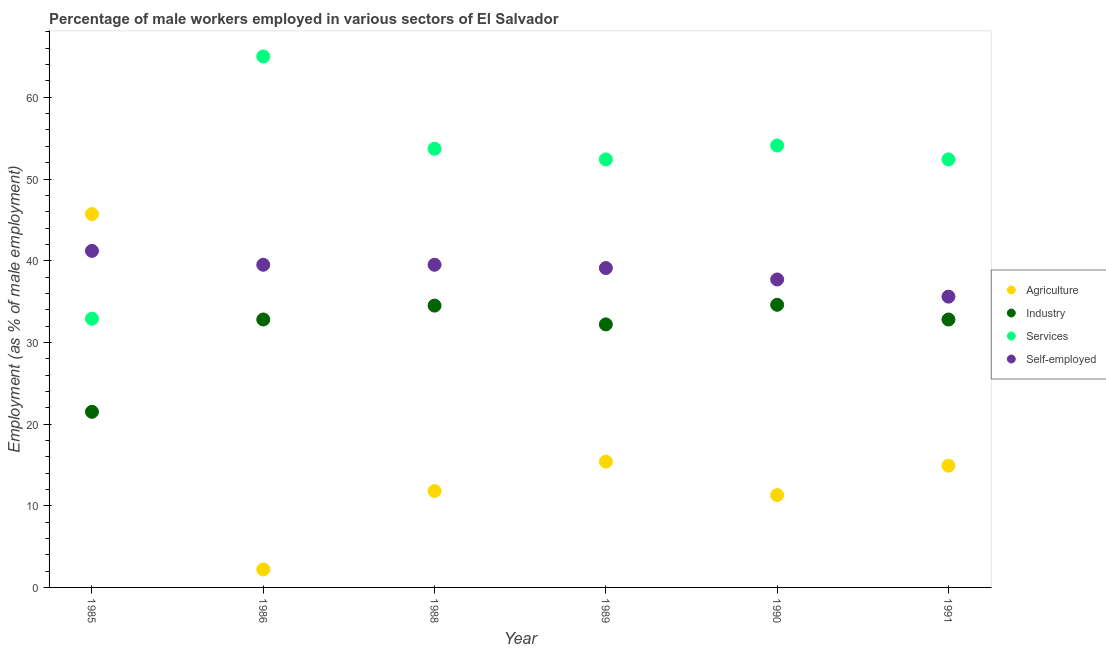How many different coloured dotlines are there?
Ensure brevity in your answer.  4. What is the percentage of male workers in agriculture in 1991?
Give a very brief answer. 14.9. Across all years, what is the maximum percentage of male workers in industry?
Your response must be concise. 34.6. Across all years, what is the minimum percentage of self employed male workers?
Give a very brief answer. 35.6. In which year was the percentage of male workers in services maximum?
Your answer should be compact. 1986. In which year was the percentage of self employed male workers minimum?
Your answer should be very brief. 1991. What is the total percentage of self employed male workers in the graph?
Your response must be concise. 232.6. What is the difference between the percentage of self employed male workers in 1985 and that in 1986?
Ensure brevity in your answer.  1.7. What is the difference between the percentage of self employed male workers in 1985 and the percentage of male workers in agriculture in 1991?
Make the answer very short. 26.3. What is the average percentage of male workers in agriculture per year?
Make the answer very short. 16.88. In the year 1990, what is the difference between the percentage of male workers in agriculture and percentage of male workers in industry?
Ensure brevity in your answer.  -23.3. What is the ratio of the percentage of male workers in industry in 1985 to that in 1989?
Offer a terse response. 0.67. What is the difference between the highest and the second highest percentage of male workers in services?
Ensure brevity in your answer.  10.9. What is the difference between the highest and the lowest percentage of male workers in agriculture?
Provide a succinct answer. 43.5. In how many years, is the percentage of male workers in industry greater than the average percentage of male workers in industry taken over all years?
Keep it short and to the point. 5. Is the sum of the percentage of self employed male workers in 1985 and 1991 greater than the maximum percentage of male workers in agriculture across all years?
Your answer should be compact. Yes. Is it the case that in every year, the sum of the percentage of male workers in industry and percentage of male workers in agriculture is greater than the sum of percentage of self employed male workers and percentage of male workers in services?
Make the answer very short. No. Is it the case that in every year, the sum of the percentage of male workers in agriculture and percentage of male workers in industry is greater than the percentage of male workers in services?
Give a very brief answer. No. Is the percentage of self employed male workers strictly less than the percentage of male workers in industry over the years?
Your answer should be very brief. No. Are the values on the major ticks of Y-axis written in scientific E-notation?
Make the answer very short. No. Does the graph contain any zero values?
Your response must be concise. No. Does the graph contain grids?
Ensure brevity in your answer.  No. Where does the legend appear in the graph?
Keep it short and to the point. Center right. What is the title of the graph?
Your response must be concise. Percentage of male workers employed in various sectors of El Salvador. Does "UNAIDS" appear as one of the legend labels in the graph?
Your response must be concise. No. What is the label or title of the X-axis?
Your answer should be compact. Year. What is the label or title of the Y-axis?
Offer a very short reply. Employment (as % of male employment). What is the Employment (as % of male employment) of Agriculture in 1985?
Provide a succinct answer. 45.7. What is the Employment (as % of male employment) of Services in 1985?
Make the answer very short. 32.9. What is the Employment (as % of male employment) in Self-employed in 1985?
Offer a very short reply. 41.2. What is the Employment (as % of male employment) of Agriculture in 1986?
Offer a terse response. 2.2. What is the Employment (as % of male employment) in Industry in 1986?
Your answer should be very brief. 32.8. What is the Employment (as % of male employment) of Self-employed in 1986?
Your answer should be compact. 39.5. What is the Employment (as % of male employment) in Agriculture in 1988?
Make the answer very short. 11.8. What is the Employment (as % of male employment) in Industry in 1988?
Provide a short and direct response. 34.5. What is the Employment (as % of male employment) of Services in 1988?
Offer a very short reply. 53.7. What is the Employment (as % of male employment) of Self-employed in 1988?
Provide a succinct answer. 39.5. What is the Employment (as % of male employment) of Agriculture in 1989?
Give a very brief answer. 15.4. What is the Employment (as % of male employment) in Industry in 1989?
Provide a succinct answer. 32.2. What is the Employment (as % of male employment) in Services in 1989?
Provide a short and direct response. 52.4. What is the Employment (as % of male employment) in Self-employed in 1989?
Offer a very short reply. 39.1. What is the Employment (as % of male employment) in Agriculture in 1990?
Make the answer very short. 11.3. What is the Employment (as % of male employment) of Industry in 1990?
Give a very brief answer. 34.6. What is the Employment (as % of male employment) in Services in 1990?
Give a very brief answer. 54.1. What is the Employment (as % of male employment) of Self-employed in 1990?
Your answer should be very brief. 37.7. What is the Employment (as % of male employment) in Agriculture in 1991?
Offer a terse response. 14.9. What is the Employment (as % of male employment) of Industry in 1991?
Give a very brief answer. 32.8. What is the Employment (as % of male employment) in Services in 1991?
Ensure brevity in your answer.  52.4. What is the Employment (as % of male employment) in Self-employed in 1991?
Provide a succinct answer. 35.6. Across all years, what is the maximum Employment (as % of male employment) in Agriculture?
Make the answer very short. 45.7. Across all years, what is the maximum Employment (as % of male employment) of Industry?
Offer a terse response. 34.6. Across all years, what is the maximum Employment (as % of male employment) of Services?
Your answer should be very brief. 65. Across all years, what is the maximum Employment (as % of male employment) of Self-employed?
Make the answer very short. 41.2. Across all years, what is the minimum Employment (as % of male employment) of Agriculture?
Offer a very short reply. 2.2. Across all years, what is the minimum Employment (as % of male employment) in Industry?
Ensure brevity in your answer.  21.5. Across all years, what is the minimum Employment (as % of male employment) of Services?
Ensure brevity in your answer.  32.9. Across all years, what is the minimum Employment (as % of male employment) of Self-employed?
Your answer should be compact. 35.6. What is the total Employment (as % of male employment) of Agriculture in the graph?
Offer a very short reply. 101.3. What is the total Employment (as % of male employment) of Industry in the graph?
Provide a succinct answer. 188.4. What is the total Employment (as % of male employment) in Services in the graph?
Your answer should be compact. 310.5. What is the total Employment (as % of male employment) in Self-employed in the graph?
Give a very brief answer. 232.6. What is the difference between the Employment (as % of male employment) in Agriculture in 1985 and that in 1986?
Provide a succinct answer. 43.5. What is the difference between the Employment (as % of male employment) in Industry in 1985 and that in 1986?
Make the answer very short. -11.3. What is the difference between the Employment (as % of male employment) of Services in 1985 and that in 1986?
Your answer should be very brief. -32.1. What is the difference between the Employment (as % of male employment) of Agriculture in 1985 and that in 1988?
Your answer should be very brief. 33.9. What is the difference between the Employment (as % of male employment) of Services in 1985 and that in 1988?
Your response must be concise. -20.8. What is the difference between the Employment (as % of male employment) in Self-employed in 1985 and that in 1988?
Your response must be concise. 1.7. What is the difference between the Employment (as % of male employment) of Agriculture in 1985 and that in 1989?
Make the answer very short. 30.3. What is the difference between the Employment (as % of male employment) in Industry in 1985 and that in 1989?
Keep it short and to the point. -10.7. What is the difference between the Employment (as % of male employment) of Services in 1985 and that in 1989?
Ensure brevity in your answer.  -19.5. What is the difference between the Employment (as % of male employment) in Self-employed in 1985 and that in 1989?
Make the answer very short. 2.1. What is the difference between the Employment (as % of male employment) of Agriculture in 1985 and that in 1990?
Your answer should be very brief. 34.4. What is the difference between the Employment (as % of male employment) in Services in 1985 and that in 1990?
Offer a terse response. -21.2. What is the difference between the Employment (as % of male employment) of Agriculture in 1985 and that in 1991?
Your answer should be compact. 30.8. What is the difference between the Employment (as % of male employment) in Services in 1985 and that in 1991?
Offer a terse response. -19.5. What is the difference between the Employment (as % of male employment) in Self-employed in 1985 and that in 1991?
Offer a terse response. 5.6. What is the difference between the Employment (as % of male employment) of Agriculture in 1986 and that in 1988?
Offer a terse response. -9.6. What is the difference between the Employment (as % of male employment) of Services in 1986 and that in 1989?
Provide a succinct answer. 12.6. What is the difference between the Employment (as % of male employment) of Agriculture in 1986 and that in 1990?
Make the answer very short. -9.1. What is the difference between the Employment (as % of male employment) in Industry in 1986 and that in 1990?
Offer a terse response. -1.8. What is the difference between the Employment (as % of male employment) of Services in 1986 and that in 1990?
Your answer should be compact. 10.9. What is the difference between the Employment (as % of male employment) in Industry in 1986 and that in 1991?
Ensure brevity in your answer.  0. What is the difference between the Employment (as % of male employment) of Self-employed in 1986 and that in 1991?
Your answer should be compact. 3.9. What is the difference between the Employment (as % of male employment) of Agriculture in 1988 and that in 1989?
Your answer should be very brief. -3.6. What is the difference between the Employment (as % of male employment) in Services in 1988 and that in 1989?
Give a very brief answer. 1.3. What is the difference between the Employment (as % of male employment) of Self-employed in 1988 and that in 1989?
Make the answer very short. 0.4. What is the difference between the Employment (as % of male employment) in Agriculture in 1988 and that in 1990?
Offer a terse response. 0.5. What is the difference between the Employment (as % of male employment) in Industry in 1988 and that in 1990?
Offer a very short reply. -0.1. What is the difference between the Employment (as % of male employment) in Services in 1988 and that in 1990?
Your response must be concise. -0.4. What is the difference between the Employment (as % of male employment) of Self-employed in 1988 and that in 1990?
Your answer should be very brief. 1.8. What is the difference between the Employment (as % of male employment) in Agriculture in 1988 and that in 1991?
Your answer should be compact. -3.1. What is the difference between the Employment (as % of male employment) in Industry in 1988 and that in 1991?
Make the answer very short. 1.7. What is the difference between the Employment (as % of male employment) of Services in 1988 and that in 1991?
Offer a terse response. 1.3. What is the difference between the Employment (as % of male employment) of Industry in 1989 and that in 1991?
Your response must be concise. -0.6. What is the difference between the Employment (as % of male employment) of Services in 1989 and that in 1991?
Give a very brief answer. 0. What is the difference between the Employment (as % of male employment) of Agriculture in 1990 and that in 1991?
Ensure brevity in your answer.  -3.6. What is the difference between the Employment (as % of male employment) of Agriculture in 1985 and the Employment (as % of male employment) of Services in 1986?
Your answer should be compact. -19.3. What is the difference between the Employment (as % of male employment) in Industry in 1985 and the Employment (as % of male employment) in Services in 1986?
Offer a very short reply. -43.5. What is the difference between the Employment (as % of male employment) of Services in 1985 and the Employment (as % of male employment) of Self-employed in 1986?
Offer a very short reply. -6.6. What is the difference between the Employment (as % of male employment) of Agriculture in 1985 and the Employment (as % of male employment) of Industry in 1988?
Offer a very short reply. 11.2. What is the difference between the Employment (as % of male employment) in Agriculture in 1985 and the Employment (as % of male employment) in Self-employed in 1988?
Keep it short and to the point. 6.2. What is the difference between the Employment (as % of male employment) in Industry in 1985 and the Employment (as % of male employment) in Services in 1988?
Provide a short and direct response. -32.2. What is the difference between the Employment (as % of male employment) in Industry in 1985 and the Employment (as % of male employment) in Self-employed in 1988?
Offer a terse response. -18. What is the difference between the Employment (as % of male employment) in Industry in 1985 and the Employment (as % of male employment) in Services in 1989?
Make the answer very short. -30.9. What is the difference between the Employment (as % of male employment) of Industry in 1985 and the Employment (as % of male employment) of Self-employed in 1989?
Make the answer very short. -17.6. What is the difference between the Employment (as % of male employment) in Services in 1985 and the Employment (as % of male employment) in Self-employed in 1989?
Keep it short and to the point. -6.2. What is the difference between the Employment (as % of male employment) in Agriculture in 1985 and the Employment (as % of male employment) in Industry in 1990?
Offer a terse response. 11.1. What is the difference between the Employment (as % of male employment) in Industry in 1985 and the Employment (as % of male employment) in Services in 1990?
Your answer should be very brief. -32.6. What is the difference between the Employment (as % of male employment) of Industry in 1985 and the Employment (as % of male employment) of Self-employed in 1990?
Your answer should be very brief. -16.2. What is the difference between the Employment (as % of male employment) in Services in 1985 and the Employment (as % of male employment) in Self-employed in 1990?
Your answer should be very brief. -4.8. What is the difference between the Employment (as % of male employment) in Agriculture in 1985 and the Employment (as % of male employment) in Industry in 1991?
Provide a succinct answer. 12.9. What is the difference between the Employment (as % of male employment) in Agriculture in 1985 and the Employment (as % of male employment) in Services in 1991?
Offer a terse response. -6.7. What is the difference between the Employment (as % of male employment) in Industry in 1985 and the Employment (as % of male employment) in Services in 1991?
Your response must be concise. -30.9. What is the difference between the Employment (as % of male employment) in Industry in 1985 and the Employment (as % of male employment) in Self-employed in 1991?
Ensure brevity in your answer.  -14.1. What is the difference between the Employment (as % of male employment) of Agriculture in 1986 and the Employment (as % of male employment) of Industry in 1988?
Your response must be concise. -32.3. What is the difference between the Employment (as % of male employment) in Agriculture in 1986 and the Employment (as % of male employment) in Services in 1988?
Your answer should be compact. -51.5. What is the difference between the Employment (as % of male employment) in Agriculture in 1986 and the Employment (as % of male employment) in Self-employed in 1988?
Provide a succinct answer. -37.3. What is the difference between the Employment (as % of male employment) of Industry in 1986 and the Employment (as % of male employment) of Services in 1988?
Offer a very short reply. -20.9. What is the difference between the Employment (as % of male employment) in Agriculture in 1986 and the Employment (as % of male employment) in Industry in 1989?
Your answer should be compact. -30. What is the difference between the Employment (as % of male employment) in Agriculture in 1986 and the Employment (as % of male employment) in Services in 1989?
Provide a succinct answer. -50.2. What is the difference between the Employment (as % of male employment) of Agriculture in 1986 and the Employment (as % of male employment) of Self-employed in 1989?
Make the answer very short. -36.9. What is the difference between the Employment (as % of male employment) in Industry in 1986 and the Employment (as % of male employment) in Services in 1989?
Provide a short and direct response. -19.6. What is the difference between the Employment (as % of male employment) of Services in 1986 and the Employment (as % of male employment) of Self-employed in 1989?
Keep it short and to the point. 25.9. What is the difference between the Employment (as % of male employment) in Agriculture in 1986 and the Employment (as % of male employment) in Industry in 1990?
Ensure brevity in your answer.  -32.4. What is the difference between the Employment (as % of male employment) of Agriculture in 1986 and the Employment (as % of male employment) of Services in 1990?
Offer a very short reply. -51.9. What is the difference between the Employment (as % of male employment) of Agriculture in 1986 and the Employment (as % of male employment) of Self-employed in 1990?
Make the answer very short. -35.5. What is the difference between the Employment (as % of male employment) of Industry in 1986 and the Employment (as % of male employment) of Services in 1990?
Offer a very short reply. -21.3. What is the difference between the Employment (as % of male employment) in Industry in 1986 and the Employment (as % of male employment) in Self-employed in 1990?
Your answer should be compact. -4.9. What is the difference between the Employment (as % of male employment) of Services in 1986 and the Employment (as % of male employment) of Self-employed in 1990?
Make the answer very short. 27.3. What is the difference between the Employment (as % of male employment) in Agriculture in 1986 and the Employment (as % of male employment) in Industry in 1991?
Offer a terse response. -30.6. What is the difference between the Employment (as % of male employment) in Agriculture in 1986 and the Employment (as % of male employment) in Services in 1991?
Your response must be concise. -50.2. What is the difference between the Employment (as % of male employment) in Agriculture in 1986 and the Employment (as % of male employment) in Self-employed in 1991?
Offer a very short reply. -33.4. What is the difference between the Employment (as % of male employment) of Industry in 1986 and the Employment (as % of male employment) of Services in 1991?
Your answer should be very brief. -19.6. What is the difference between the Employment (as % of male employment) of Industry in 1986 and the Employment (as % of male employment) of Self-employed in 1991?
Provide a short and direct response. -2.8. What is the difference between the Employment (as % of male employment) in Services in 1986 and the Employment (as % of male employment) in Self-employed in 1991?
Provide a short and direct response. 29.4. What is the difference between the Employment (as % of male employment) in Agriculture in 1988 and the Employment (as % of male employment) in Industry in 1989?
Offer a very short reply. -20.4. What is the difference between the Employment (as % of male employment) in Agriculture in 1988 and the Employment (as % of male employment) in Services in 1989?
Your response must be concise. -40.6. What is the difference between the Employment (as % of male employment) of Agriculture in 1988 and the Employment (as % of male employment) of Self-employed in 1989?
Your answer should be compact. -27.3. What is the difference between the Employment (as % of male employment) of Industry in 1988 and the Employment (as % of male employment) of Services in 1989?
Your answer should be very brief. -17.9. What is the difference between the Employment (as % of male employment) in Agriculture in 1988 and the Employment (as % of male employment) in Industry in 1990?
Offer a terse response. -22.8. What is the difference between the Employment (as % of male employment) in Agriculture in 1988 and the Employment (as % of male employment) in Services in 1990?
Offer a terse response. -42.3. What is the difference between the Employment (as % of male employment) of Agriculture in 1988 and the Employment (as % of male employment) of Self-employed in 1990?
Offer a very short reply. -25.9. What is the difference between the Employment (as % of male employment) in Industry in 1988 and the Employment (as % of male employment) in Services in 1990?
Provide a succinct answer. -19.6. What is the difference between the Employment (as % of male employment) in Industry in 1988 and the Employment (as % of male employment) in Self-employed in 1990?
Provide a short and direct response. -3.2. What is the difference between the Employment (as % of male employment) in Services in 1988 and the Employment (as % of male employment) in Self-employed in 1990?
Give a very brief answer. 16. What is the difference between the Employment (as % of male employment) of Agriculture in 1988 and the Employment (as % of male employment) of Industry in 1991?
Keep it short and to the point. -21. What is the difference between the Employment (as % of male employment) of Agriculture in 1988 and the Employment (as % of male employment) of Services in 1991?
Keep it short and to the point. -40.6. What is the difference between the Employment (as % of male employment) of Agriculture in 1988 and the Employment (as % of male employment) of Self-employed in 1991?
Your answer should be compact. -23.8. What is the difference between the Employment (as % of male employment) of Industry in 1988 and the Employment (as % of male employment) of Services in 1991?
Provide a short and direct response. -17.9. What is the difference between the Employment (as % of male employment) in Services in 1988 and the Employment (as % of male employment) in Self-employed in 1991?
Keep it short and to the point. 18.1. What is the difference between the Employment (as % of male employment) in Agriculture in 1989 and the Employment (as % of male employment) in Industry in 1990?
Give a very brief answer. -19.2. What is the difference between the Employment (as % of male employment) in Agriculture in 1989 and the Employment (as % of male employment) in Services in 1990?
Offer a very short reply. -38.7. What is the difference between the Employment (as % of male employment) in Agriculture in 1989 and the Employment (as % of male employment) in Self-employed in 1990?
Ensure brevity in your answer.  -22.3. What is the difference between the Employment (as % of male employment) of Industry in 1989 and the Employment (as % of male employment) of Services in 1990?
Your answer should be very brief. -21.9. What is the difference between the Employment (as % of male employment) in Agriculture in 1989 and the Employment (as % of male employment) in Industry in 1991?
Give a very brief answer. -17.4. What is the difference between the Employment (as % of male employment) of Agriculture in 1989 and the Employment (as % of male employment) of Services in 1991?
Give a very brief answer. -37. What is the difference between the Employment (as % of male employment) in Agriculture in 1989 and the Employment (as % of male employment) in Self-employed in 1991?
Your answer should be compact. -20.2. What is the difference between the Employment (as % of male employment) in Industry in 1989 and the Employment (as % of male employment) in Services in 1991?
Keep it short and to the point. -20.2. What is the difference between the Employment (as % of male employment) of Services in 1989 and the Employment (as % of male employment) of Self-employed in 1991?
Give a very brief answer. 16.8. What is the difference between the Employment (as % of male employment) in Agriculture in 1990 and the Employment (as % of male employment) in Industry in 1991?
Your answer should be compact. -21.5. What is the difference between the Employment (as % of male employment) of Agriculture in 1990 and the Employment (as % of male employment) of Services in 1991?
Ensure brevity in your answer.  -41.1. What is the difference between the Employment (as % of male employment) of Agriculture in 1990 and the Employment (as % of male employment) of Self-employed in 1991?
Offer a terse response. -24.3. What is the difference between the Employment (as % of male employment) of Industry in 1990 and the Employment (as % of male employment) of Services in 1991?
Give a very brief answer. -17.8. What is the difference between the Employment (as % of male employment) in Industry in 1990 and the Employment (as % of male employment) in Self-employed in 1991?
Provide a short and direct response. -1. What is the difference between the Employment (as % of male employment) of Services in 1990 and the Employment (as % of male employment) of Self-employed in 1991?
Offer a very short reply. 18.5. What is the average Employment (as % of male employment) in Agriculture per year?
Your answer should be compact. 16.88. What is the average Employment (as % of male employment) in Industry per year?
Offer a terse response. 31.4. What is the average Employment (as % of male employment) in Services per year?
Ensure brevity in your answer.  51.75. What is the average Employment (as % of male employment) of Self-employed per year?
Your answer should be very brief. 38.77. In the year 1985, what is the difference between the Employment (as % of male employment) of Agriculture and Employment (as % of male employment) of Industry?
Offer a very short reply. 24.2. In the year 1985, what is the difference between the Employment (as % of male employment) in Agriculture and Employment (as % of male employment) in Services?
Offer a very short reply. 12.8. In the year 1985, what is the difference between the Employment (as % of male employment) of Industry and Employment (as % of male employment) of Self-employed?
Your response must be concise. -19.7. In the year 1986, what is the difference between the Employment (as % of male employment) in Agriculture and Employment (as % of male employment) in Industry?
Offer a terse response. -30.6. In the year 1986, what is the difference between the Employment (as % of male employment) of Agriculture and Employment (as % of male employment) of Services?
Your answer should be very brief. -62.8. In the year 1986, what is the difference between the Employment (as % of male employment) of Agriculture and Employment (as % of male employment) of Self-employed?
Your response must be concise. -37.3. In the year 1986, what is the difference between the Employment (as % of male employment) in Industry and Employment (as % of male employment) in Services?
Your answer should be compact. -32.2. In the year 1986, what is the difference between the Employment (as % of male employment) in Services and Employment (as % of male employment) in Self-employed?
Give a very brief answer. 25.5. In the year 1988, what is the difference between the Employment (as % of male employment) of Agriculture and Employment (as % of male employment) of Industry?
Ensure brevity in your answer.  -22.7. In the year 1988, what is the difference between the Employment (as % of male employment) of Agriculture and Employment (as % of male employment) of Services?
Keep it short and to the point. -41.9. In the year 1988, what is the difference between the Employment (as % of male employment) in Agriculture and Employment (as % of male employment) in Self-employed?
Ensure brevity in your answer.  -27.7. In the year 1988, what is the difference between the Employment (as % of male employment) in Industry and Employment (as % of male employment) in Services?
Your response must be concise. -19.2. In the year 1988, what is the difference between the Employment (as % of male employment) in Industry and Employment (as % of male employment) in Self-employed?
Make the answer very short. -5. In the year 1988, what is the difference between the Employment (as % of male employment) in Services and Employment (as % of male employment) in Self-employed?
Provide a succinct answer. 14.2. In the year 1989, what is the difference between the Employment (as % of male employment) of Agriculture and Employment (as % of male employment) of Industry?
Provide a succinct answer. -16.8. In the year 1989, what is the difference between the Employment (as % of male employment) in Agriculture and Employment (as % of male employment) in Services?
Your answer should be very brief. -37. In the year 1989, what is the difference between the Employment (as % of male employment) of Agriculture and Employment (as % of male employment) of Self-employed?
Keep it short and to the point. -23.7. In the year 1989, what is the difference between the Employment (as % of male employment) of Industry and Employment (as % of male employment) of Services?
Offer a very short reply. -20.2. In the year 1989, what is the difference between the Employment (as % of male employment) of Industry and Employment (as % of male employment) of Self-employed?
Keep it short and to the point. -6.9. In the year 1989, what is the difference between the Employment (as % of male employment) in Services and Employment (as % of male employment) in Self-employed?
Give a very brief answer. 13.3. In the year 1990, what is the difference between the Employment (as % of male employment) of Agriculture and Employment (as % of male employment) of Industry?
Ensure brevity in your answer.  -23.3. In the year 1990, what is the difference between the Employment (as % of male employment) of Agriculture and Employment (as % of male employment) of Services?
Ensure brevity in your answer.  -42.8. In the year 1990, what is the difference between the Employment (as % of male employment) in Agriculture and Employment (as % of male employment) in Self-employed?
Ensure brevity in your answer.  -26.4. In the year 1990, what is the difference between the Employment (as % of male employment) in Industry and Employment (as % of male employment) in Services?
Keep it short and to the point. -19.5. In the year 1991, what is the difference between the Employment (as % of male employment) of Agriculture and Employment (as % of male employment) of Industry?
Your answer should be very brief. -17.9. In the year 1991, what is the difference between the Employment (as % of male employment) in Agriculture and Employment (as % of male employment) in Services?
Ensure brevity in your answer.  -37.5. In the year 1991, what is the difference between the Employment (as % of male employment) in Agriculture and Employment (as % of male employment) in Self-employed?
Ensure brevity in your answer.  -20.7. In the year 1991, what is the difference between the Employment (as % of male employment) in Industry and Employment (as % of male employment) in Services?
Your response must be concise. -19.6. In the year 1991, what is the difference between the Employment (as % of male employment) in Industry and Employment (as % of male employment) in Self-employed?
Keep it short and to the point. -2.8. In the year 1991, what is the difference between the Employment (as % of male employment) of Services and Employment (as % of male employment) of Self-employed?
Offer a terse response. 16.8. What is the ratio of the Employment (as % of male employment) of Agriculture in 1985 to that in 1986?
Your response must be concise. 20.77. What is the ratio of the Employment (as % of male employment) in Industry in 1985 to that in 1986?
Provide a succinct answer. 0.66. What is the ratio of the Employment (as % of male employment) of Services in 1985 to that in 1986?
Your answer should be compact. 0.51. What is the ratio of the Employment (as % of male employment) of Self-employed in 1985 to that in 1986?
Ensure brevity in your answer.  1.04. What is the ratio of the Employment (as % of male employment) in Agriculture in 1985 to that in 1988?
Make the answer very short. 3.87. What is the ratio of the Employment (as % of male employment) in Industry in 1985 to that in 1988?
Keep it short and to the point. 0.62. What is the ratio of the Employment (as % of male employment) of Services in 1985 to that in 1988?
Your answer should be very brief. 0.61. What is the ratio of the Employment (as % of male employment) of Self-employed in 1985 to that in 1988?
Make the answer very short. 1.04. What is the ratio of the Employment (as % of male employment) in Agriculture in 1985 to that in 1989?
Provide a short and direct response. 2.97. What is the ratio of the Employment (as % of male employment) of Industry in 1985 to that in 1989?
Your answer should be very brief. 0.67. What is the ratio of the Employment (as % of male employment) of Services in 1985 to that in 1989?
Ensure brevity in your answer.  0.63. What is the ratio of the Employment (as % of male employment) of Self-employed in 1985 to that in 1989?
Your answer should be very brief. 1.05. What is the ratio of the Employment (as % of male employment) in Agriculture in 1985 to that in 1990?
Ensure brevity in your answer.  4.04. What is the ratio of the Employment (as % of male employment) of Industry in 1985 to that in 1990?
Your response must be concise. 0.62. What is the ratio of the Employment (as % of male employment) of Services in 1985 to that in 1990?
Give a very brief answer. 0.61. What is the ratio of the Employment (as % of male employment) of Self-employed in 1985 to that in 1990?
Ensure brevity in your answer.  1.09. What is the ratio of the Employment (as % of male employment) of Agriculture in 1985 to that in 1991?
Your response must be concise. 3.07. What is the ratio of the Employment (as % of male employment) of Industry in 1985 to that in 1991?
Your answer should be very brief. 0.66. What is the ratio of the Employment (as % of male employment) of Services in 1985 to that in 1991?
Provide a short and direct response. 0.63. What is the ratio of the Employment (as % of male employment) in Self-employed in 1985 to that in 1991?
Your answer should be compact. 1.16. What is the ratio of the Employment (as % of male employment) of Agriculture in 1986 to that in 1988?
Keep it short and to the point. 0.19. What is the ratio of the Employment (as % of male employment) of Industry in 1986 to that in 1988?
Make the answer very short. 0.95. What is the ratio of the Employment (as % of male employment) of Services in 1986 to that in 1988?
Your answer should be compact. 1.21. What is the ratio of the Employment (as % of male employment) in Self-employed in 1986 to that in 1988?
Your answer should be very brief. 1. What is the ratio of the Employment (as % of male employment) of Agriculture in 1986 to that in 1989?
Your answer should be very brief. 0.14. What is the ratio of the Employment (as % of male employment) of Industry in 1986 to that in 1989?
Your response must be concise. 1.02. What is the ratio of the Employment (as % of male employment) in Services in 1986 to that in 1989?
Provide a short and direct response. 1.24. What is the ratio of the Employment (as % of male employment) in Self-employed in 1986 to that in 1989?
Your answer should be compact. 1.01. What is the ratio of the Employment (as % of male employment) in Agriculture in 1986 to that in 1990?
Your answer should be very brief. 0.19. What is the ratio of the Employment (as % of male employment) in Industry in 1986 to that in 1990?
Provide a short and direct response. 0.95. What is the ratio of the Employment (as % of male employment) in Services in 1986 to that in 1990?
Provide a succinct answer. 1.2. What is the ratio of the Employment (as % of male employment) in Self-employed in 1986 to that in 1990?
Provide a succinct answer. 1.05. What is the ratio of the Employment (as % of male employment) of Agriculture in 1986 to that in 1991?
Make the answer very short. 0.15. What is the ratio of the Employment (as % of male employment) in Industry in 1986 to that in 1991?
Give a very brief answer. 1. What is the ratio of the Employment (as % of male employment) in Services in 1986 to that in 1991?
Keep it short and to the point. 1.24. What is the ratio of the Employment (as % of male employment) of Self-employed in 1986 to that in 1991?
Offer a very short reply. 1.11. What is the ratio of the Employment (as % of male employment) of Agriculture in 1988 to that in 1989?
Ensure brevity in your answer.  0.77. What is the ratio of the Employment (as % of male employment) of Industry in 1988 to that in 1989?
Keep it short and to the point. 1.07. What is the ratio of the Employment (as % of male employment) in Services in 1988 to that in 1989?
Make the answer very short. 1.02. What is the ratio of the Employment (as % of male employment) in Self-employed in 1988 to that in 1989?
Offer a very short reply. 1.01. What is the ratio of the Employment (as % of male employment) of Agriculture in 1988 to that in 1990?
Give a very brief answer. 1.04. What is the ratio of the Employment (as % of male employment) in Services in 1988 to that in 1990?
Offer a very short reply. 0.99. What is the ratio of the Employment (as % of male employment) in Self-employed in 1988 to that in 1990?
Offer a terse response. 1.05. What is the ratio of the Employment (as % of male employment) of Agriculture in 1988 to that in 1991?
Ensure brevity in your answer.  0.79. What is the ratio of the Employment (as % of male employment) in Industry in 1988 to that in 1991?
Your answer should be compact. 1.05. What is the ratio of the Employment (as % of male employment) of Services in 1988 to that in 1991?
Your response must be concise. 1.02. What is the ratio of the Employment (as % of male employment) of Self-employed in 1988 to that in 1991?
Offer a very short reply. 1.11. What is the ratio of the Employment (as % of male employment) in Agriculture in 1989 to that in 1990?
Provide a succinct answer. 1.36. What is the ratio of the Employment (as % of male employment) in Industry in 1989 to that in 1990?
Make the answer very short. 0.93. What is the ratio of the Employment (as % of male employment) in Services in 1989 to that in 1990?
Give a very brief answer. 0.97. What is the ratio of the Employment (as % of male employment) in Self-employed in 1989 to that in 1990?
Keep it short and to the point. 1.04. What is the ratio of the Employment (as % of male employment) in Agriculture in 1989 to that in 1991?
Make the answer very short. 1.03. What is the ratio of the Employment (as % of male employment) in Industry in 1989 to that in 1991?
Provide a succinct answer. 0.98. What is the ratio of the Employment (as % of male employment) of Services in 1989 to that in 1991?
Offer a terse response. 1. What is the ratio of the Employment (as % of male employment) in Self-employed in 1989 to that in 1991?
Ensure brevity in your answer.  1.1. What is the ratio of the Employment (as % of male employment) in Agriculture in 1990 to that in 1991?
Ensure brevity in your answer.  0.76. What is the ratio of the Employment (as % of male employment) of Industry in 1990 to that in 1991?
Your answer should be compact. 1.05. What is the ratio of the Employment (as % of male employment) of Services in 1990 to that in 1991?
Ensure brevity in your answer.  1.03. What is the ratio of the Employment (as % of male employment) in Self-employed in 1990 to that in 1991?
Your answer should be very brief. 1.06. What is the difference between the highest and the second highest Employment (as % of male employment) in Agriculture?
Your answer should be compact. 30.3. What is the difference between the highest and the lowest Employment (as % of male employment) of Agriculture?
Give a very brief answer. 43.5. What is the difference between the highest and the lowest Employment (as % of male employment) of Industry?
Your answer should be very brief. 13.1. What is the difference between the highest and the lowest Employment (as % of male employment) of Services?
Provide a succinct answer. 32.1. 